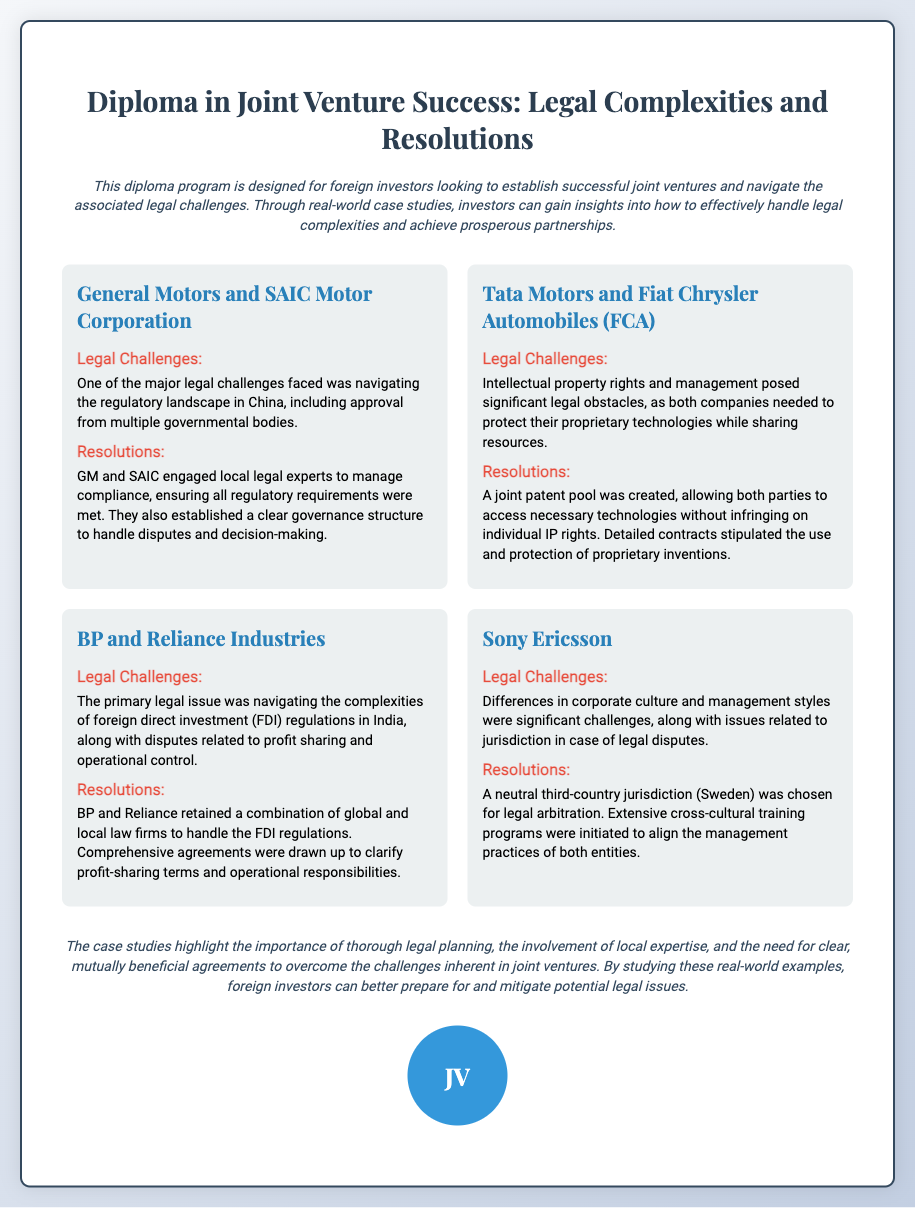What is the title of the diploma? The title of the diploma is prominently displayed at the top of the document.
Answer: Diploma in Joint Venture Success: Legal Complexities and Resolutions Who are the partners in the first case study? The first case study outlines the partnership between General Motors and SAIC Motor Corporation.
Answer: General Motors and SAIC Motor Corporation What was one major legal challenge faced by Tata Motors and FCA? The document specifies that one legal challenge involved intellectual property rights and management.
Answer: Intellectual property rights Which country’s regulations were a challenge in the BP and Reliance case? The primary legal issue regarding foreign direct investment (FDI) regulations was specifically related to India.
Answer: India What resolution was chosen for legal arbitration in the Sony Ericsson case? The document states that a neutral third-country jurisdiction, specifically Sweden, was selected for arbitration.
Answer: Sweden What legal strategy did GM and SAIC employ to manage compliance? The case study indicates that GM and SAIC engaged local legal experts for compliance management.
Answer: Local legal experts What does the conclusion emphasize as crucial for overcoming joint venture challenges? The conclusion highlights the importance of thorough legal planning, local expertise, and clear agreements.
Answer: Thorough legal planning How many case studies are presented in the document? By counting, we see that there are four distinct case studies included in the document.
Answer: Four 